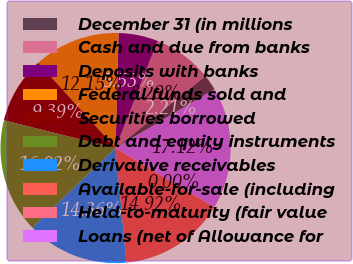<chart> <loc_0><loc_0><loc_500><loc_500><pie_chart><fcel>December 31 (in millions<fcel>Cash and due from banks<fcel>Deposits with banks<fcel>Federal funds sold and<fcel>Securities borrowed<fcel>Debt and equity instruments<fcel>Derivative receivables<fcel>Available-for-sale (including<fcel>Held-to-maturity (fair value<fcel>Loans (net of Allowance for<nl><fcel>2.21%<fcel>8.29%<fcel>5.53%<fcel>12.15%<fcel>9.39%<fcel>16.02%<fcel>14.36%<fcel>14.92%<fcel>0.0%<fcel>17.12%<nl></chart> 